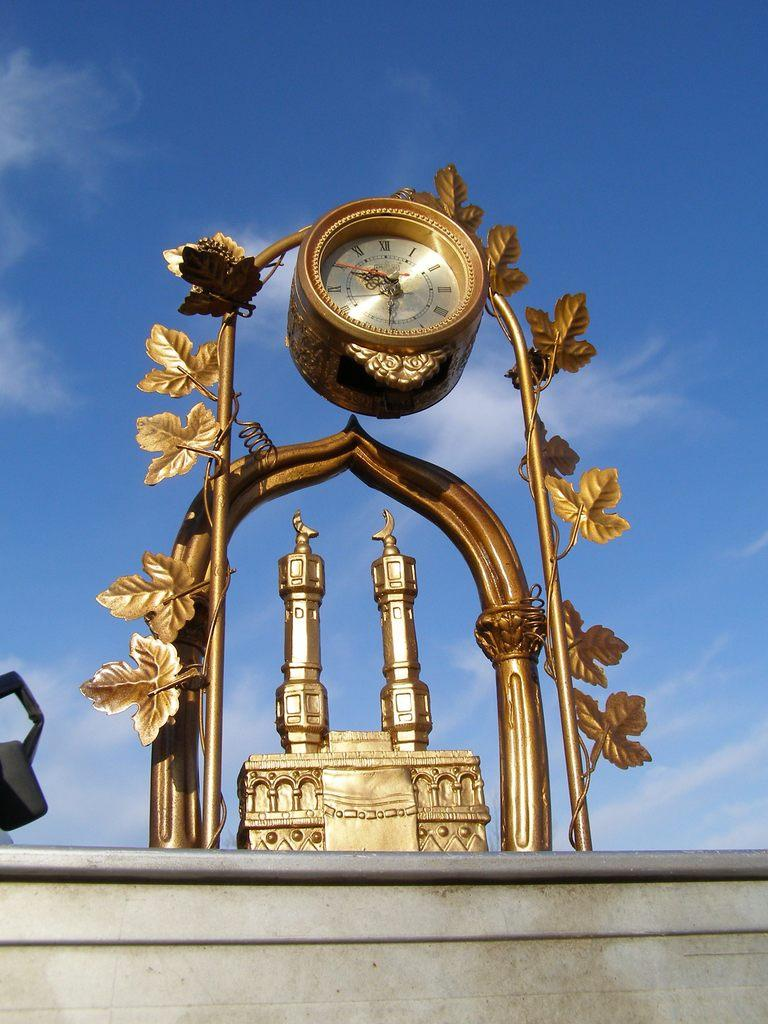What structure with a clock is present in the image? There is an arch with a clock in the image. What type of building is depicted in the image? The image depicts a mosque. What can be seen in the background of the image? There is sky visible in the background of the image, with clouds present. What is at the bottom of the image? There is a wall at the bottom of the image. What type of brass instrument is being played in the image? There is no brass instrument present in the image; it features an arch with a clock and a mosque. What type of lunch is being served in the image? There is no lunch depicted in the image; it focuses on the architectural elements of the mosque and the clock. 